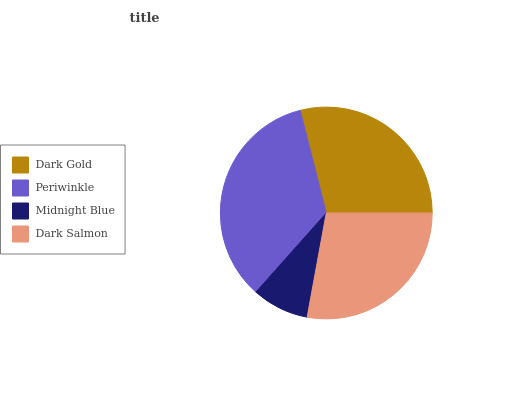Is Midnight Blue the minimum?
Answer yes or no. Yes. Is Periwinkle the maximum?
Answer yes or no. Yes. Is Periwinkle the minimum?
Answer yes or no. No. Is Midnight Blue the maximum?
Answer yes or no. No. Is Periwinkle greater than Midnight Blue?
Answer yes or no. Yes. Is Midnight Blue less than Periwinkle?
Answer yes or no. Yes. Is Midnight Blue greater than Periwinkle?
Answer yes or no. No. Is Periwinkle less than Midnight Blue?
Answer yes or no. No. Is Dark Gold the high median?
Answer yes or no. Yes. Is Dark Salmon the low median?
Answer yes or no. Yes. Is Periwinkle the high median?
Answer yes or no. No. Is Periwinkle the low median?
Answer yes or no. No. 